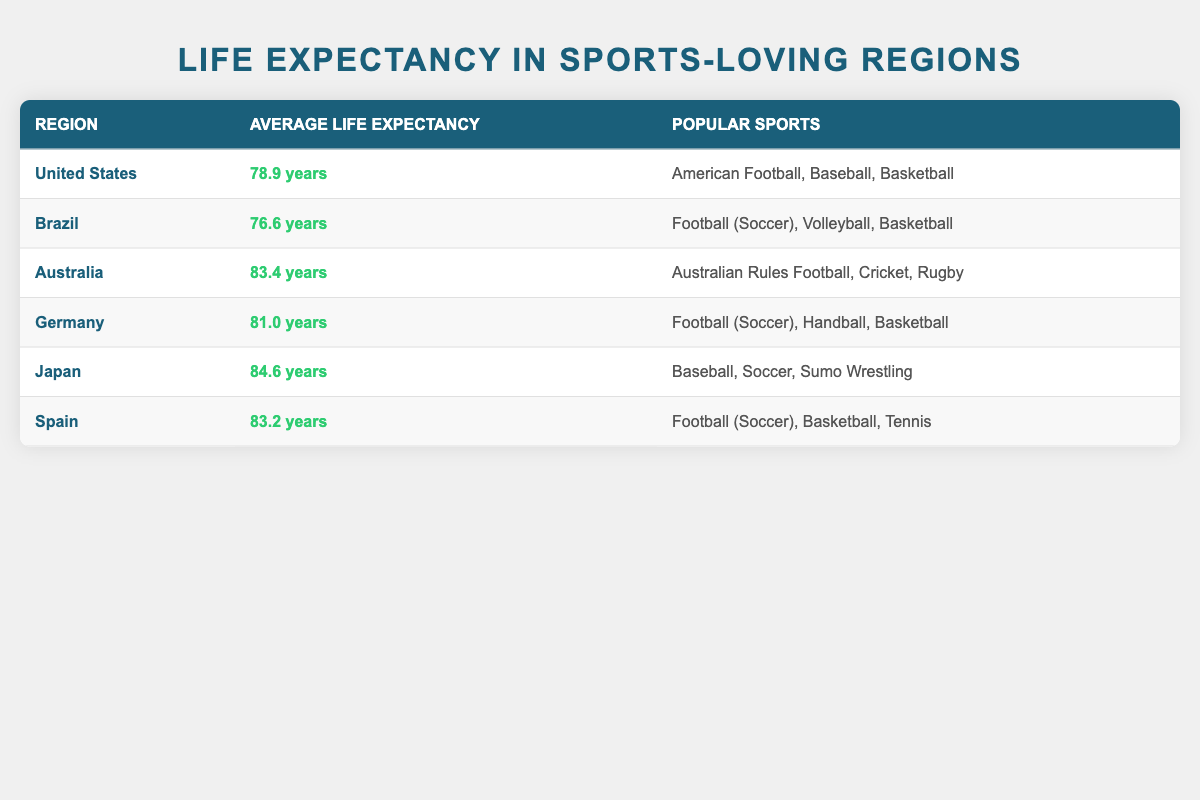What is the average life expectancy in Japan? The life expectancy for Japan is specifically listed in the table, which states it as 84.6 years.
Answer: 84.6 years Which region has the lowest average life expectancy? By reviewing the life expectancy values for all regions, Brazil has the lowest average at 76.6 years, while other regions have higher values.
Answer: Brazil What is the average life expectancy of the United States and Germany combined? To calculate the average, we sum the life expectancies of the United States (78.9) and Germany (81.0) which is 78.9 + 81.0 = 159.9. Then, dividing by 2 gives us the average: 159.9 / 2 = 79.95.
Answer: 79.95 years Is the average life expectancy in Australia greater than 82 years? The table indicates Australia's average life expectancy is 83.4 years, which is greater than 82 years.
Answer: Yes What is the difference in average life expectancy between Japan and Spain? The average life expectancy in Japan is 84.6 years, and in Spain, it is 83.2 years. Subtracting these values gives 84.6 - 83.2 = 1.4 years.
Answer: 1.4 years How many regions listed have Football (Soccer) as a popular sport? By checking the popular sports in each region, we find that Football (Soccer) is mentioned in Brazil, Germany, Spain, and Japan. That totals four regions.
Answer: 4 regions Which region has the highest life expectancy and what is it? Looking at the life expectancy figures, Japan shows the highest value at 84.6 years, higher than the next closest region, Australia.
Answer: Japan, 84.6 years Are there any regions where Basketball is a popular sport with an average life expectancy over 80 years? The table shows that Basketball is popular in the United States, Germany, and Spain. Examining their life expectancies: US (78.9), Germany (81.0), and Spain (83.2) reveals that Germany and Spain meet the condition of being over 80 years.
Answer: Yes, Germany and Spain What is the average life expectancy across all the regions listed? To find the average, we sum each region's life expectancy: 78.9 + 76.6 + 83.4 + 81.0 + 84.6 + 83.2 = 488.7 years. There are 6 regions, so we divide 488.7 by 6, resulting in an average of approximately 81.45 years.
Answer: 81.45 years 